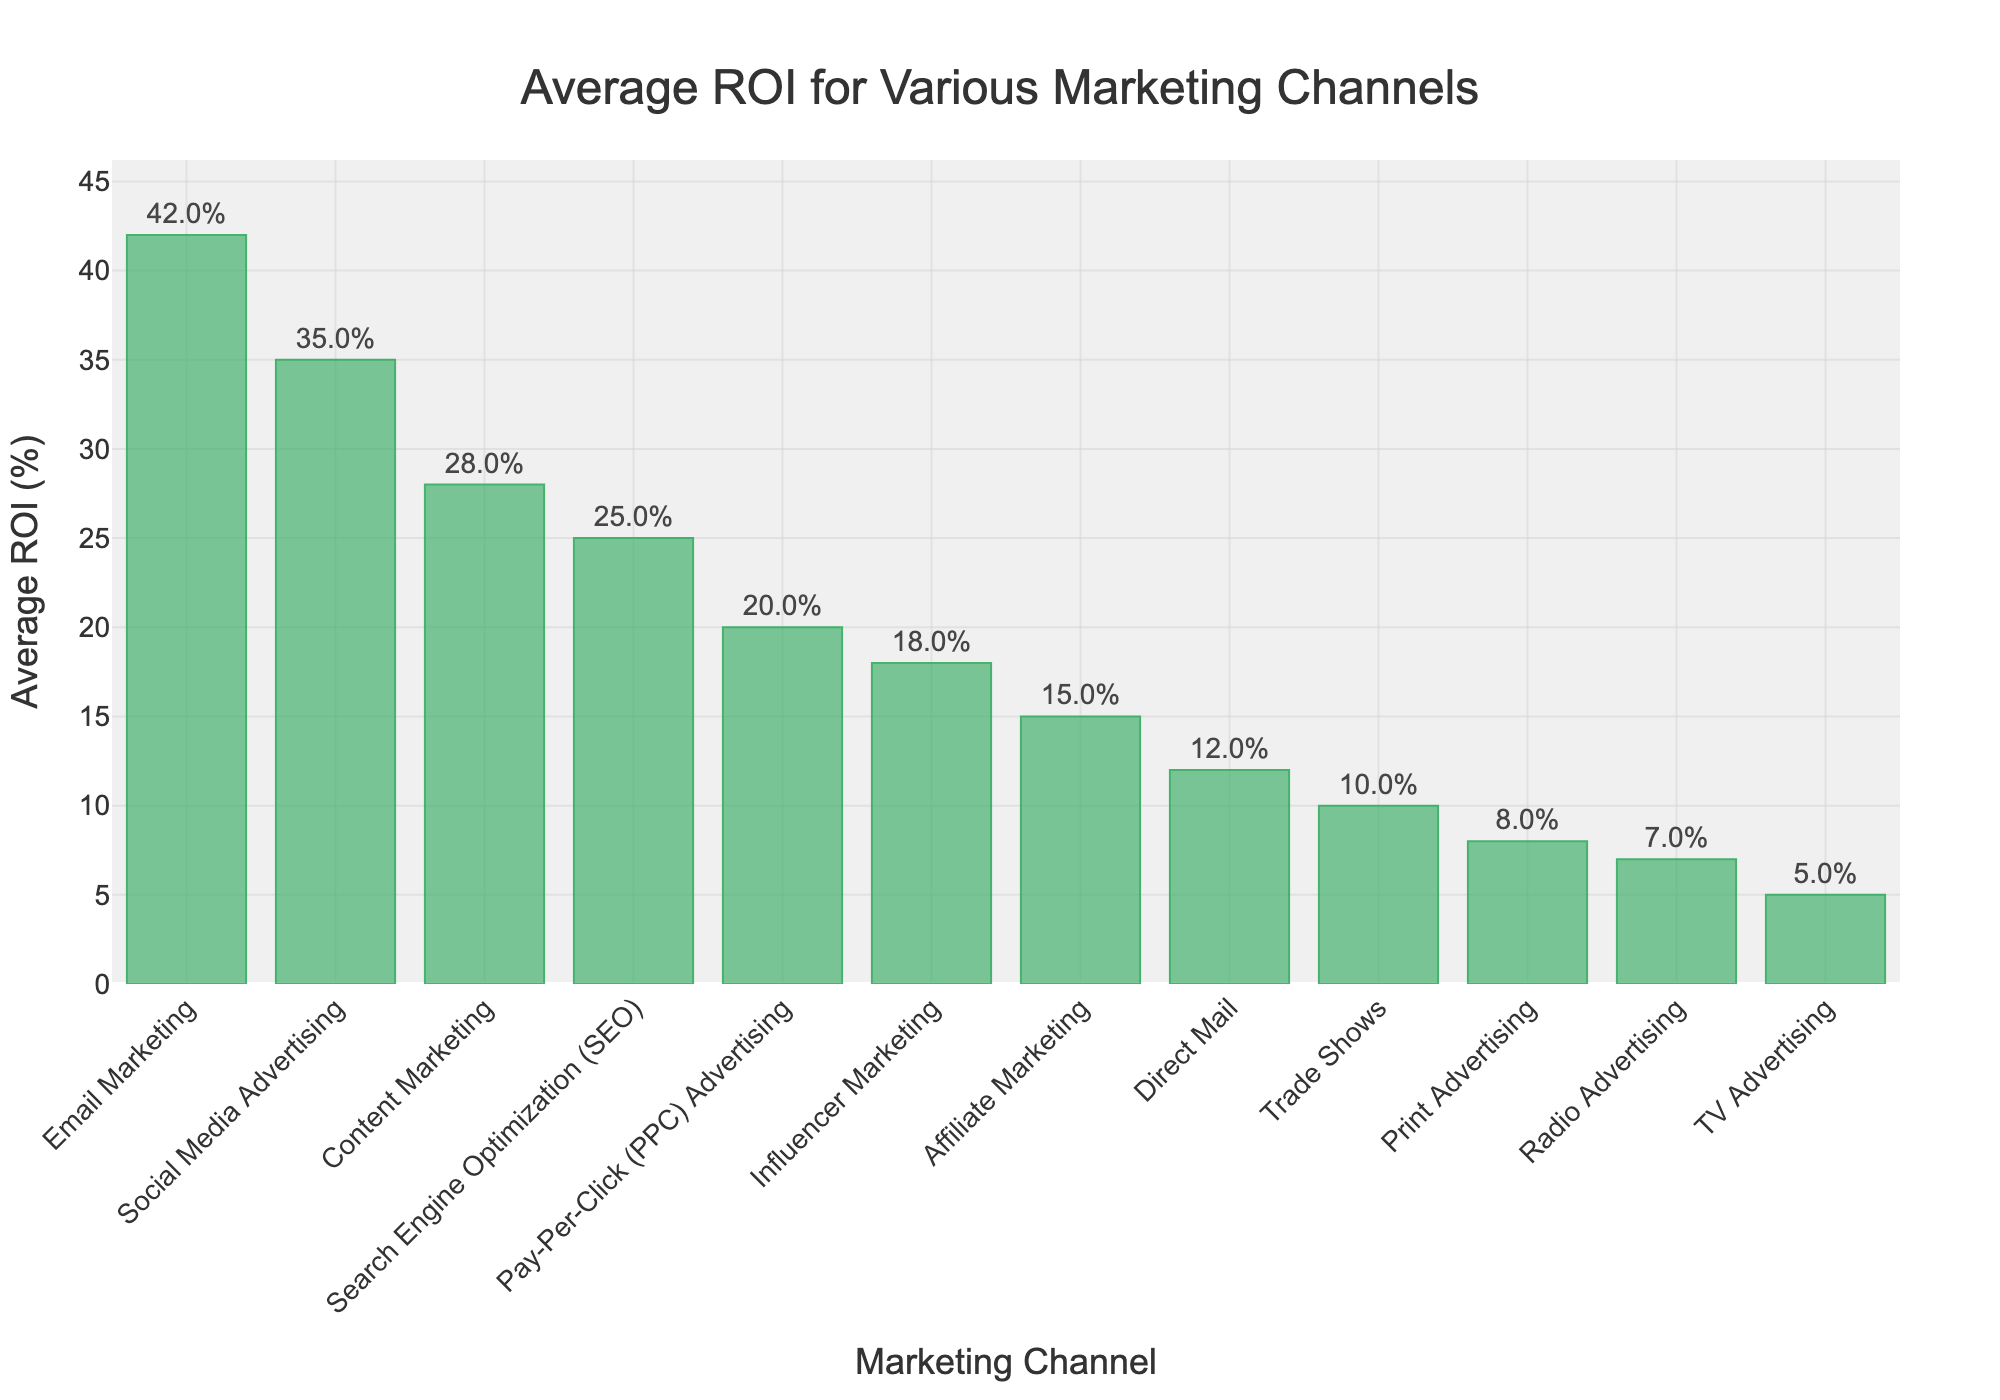What is the marketing channel with the highest average ROI? By looking at the top of the bar chart, the highest bar represents the marketing channel with the highest average ROI. In this case, it is Email Marketing.
Answer: Email Marketing Which marketing channel has a higher average ROI: Social Media Advertising or Content Marketing? Compare the heights of the bars for Social Media Advertising and Content Marketing. The bar for Social Media Advertising is higher.
Answer: Social Media Advertising What is the difference in average ROI between SEO and TV Advertising? To find the difference, look at the heights of the bars for SEO and TV Advertising. SEO has an average ROI of 25%, and TV Advertising has 5%. Subtracting these values gives 25% - 5% = 20%.
Answer: 20% How many marketing channels have an average ROI of 20% or higher? Count the number of bars with heights corresponding to an average ROI of 20% or more. These are Email Marketing (42%), Social Media Advertising (35%), Content Marketing (28%), SEO (25%), and PPC Advertising (20%). Five marketing channels meet this criterion.
Answer: 5 What is the average ROI of the top three marketing channels combined? Sum the average ROIs of the top three marketing channels: Email Marketing (42%), Social Media Advertising (35%), and Content Marketing (28%). The sum is 42% + 35% + 28% = 105%. The average is 105% / 3 = 35%.
Answer: 35% Which marketing channels have a lower average ROI than Affiliate Marketing? Identify the bars for marketing channels with ROIs lower than Affiliate Marketing (15%). These are Direct Mail (12%), Trade Shows (10%), Print Advertising (8%), Radio Advertising (7%), and TV Advertising (5%).
Answer: Direct Mail, Trade Shows, Print Advertising, Radio Advertising, TV Advertising What is the median average ROI of all the marketing channels? To find the median, order the average ROIs and identify the middle value. The ordered ROIs are 5%, 7%, 8%, 10%, 12%, 15%, 18%, 20%, 25%, 28%, 35%, 42%. The median is between the 6th and 7th values (15% and 18%), so the median is (15% + 18%) / 2 = 16.5%.
Answer: 16.5% Is the average ROI of PPC Advertising more or less than half of the ROI of Email Marketing? Compare half of the average ROI of Email Marketing (42% / 2 = 21%) to the average ROI of PPC Advertising (20%). Since 21% > 20%, PPC Advertising's ROI is less than half of Email Marketing's ROI.
Answer: Less Which two marketing channels have the closest average ROI values? Compare the differences between the average ROI values of adjacent bars. The smallest difference is between Print Advertising (8%) and Radio Advertising (7%), which is 1%.
Answer: Print Advertising and Radio Advertising 